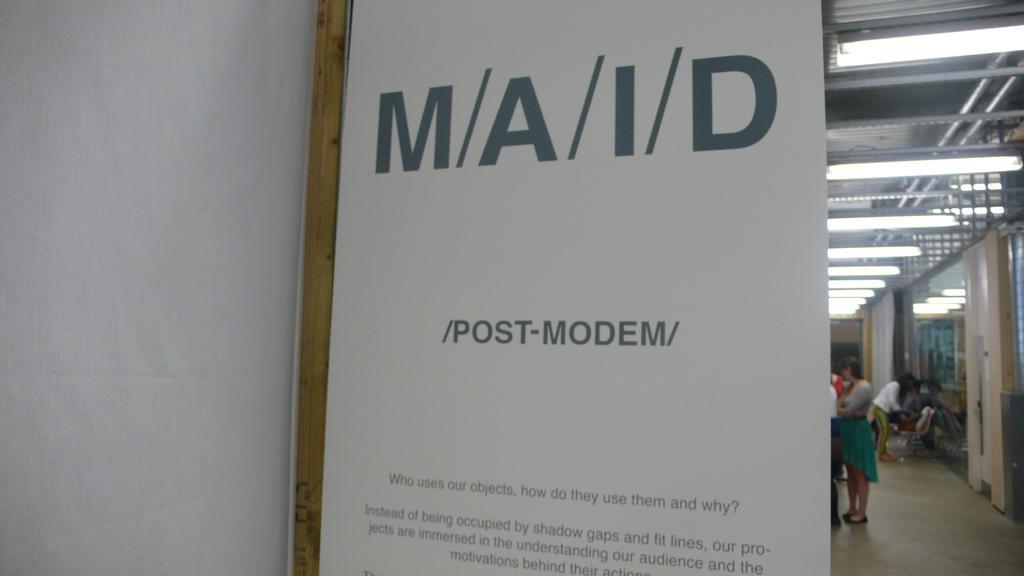Could you give a brief overview of what you see in this image? In front of the picture, we see a white color board or a banner with some text written on it. Behind that, we see people standing. On the right side, we see glass doors and curtains in white color. At the top of the picture, we see the lights and the ceiling of the room. On the left side, we see a white wall. 